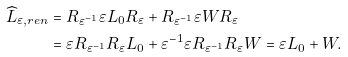<formula> <loc_0><loc_0><loc_500><loc_500>\widehat { L } _ { \varepsilon , r e n } & = R _ { \varepsilon ^ { - 1 } } \varepsilon L _ { 0 } R _ { \varepsilon } + R _ { \varepsilon ^ { - 1 } } \varepsilon W R _ { \varepsilon } \\ & = \varepsilon R _ { \varepsilon ^ { - 1 } } R _ { \varepsilon } L _ { 0 } + \varepsilon ^ { - 1 } \varepsilon R _ { \varepsilon ^ { - 1 } } R _ { \varepsilon } W = \varepsilon L _ { 0 } + W .</formula> 